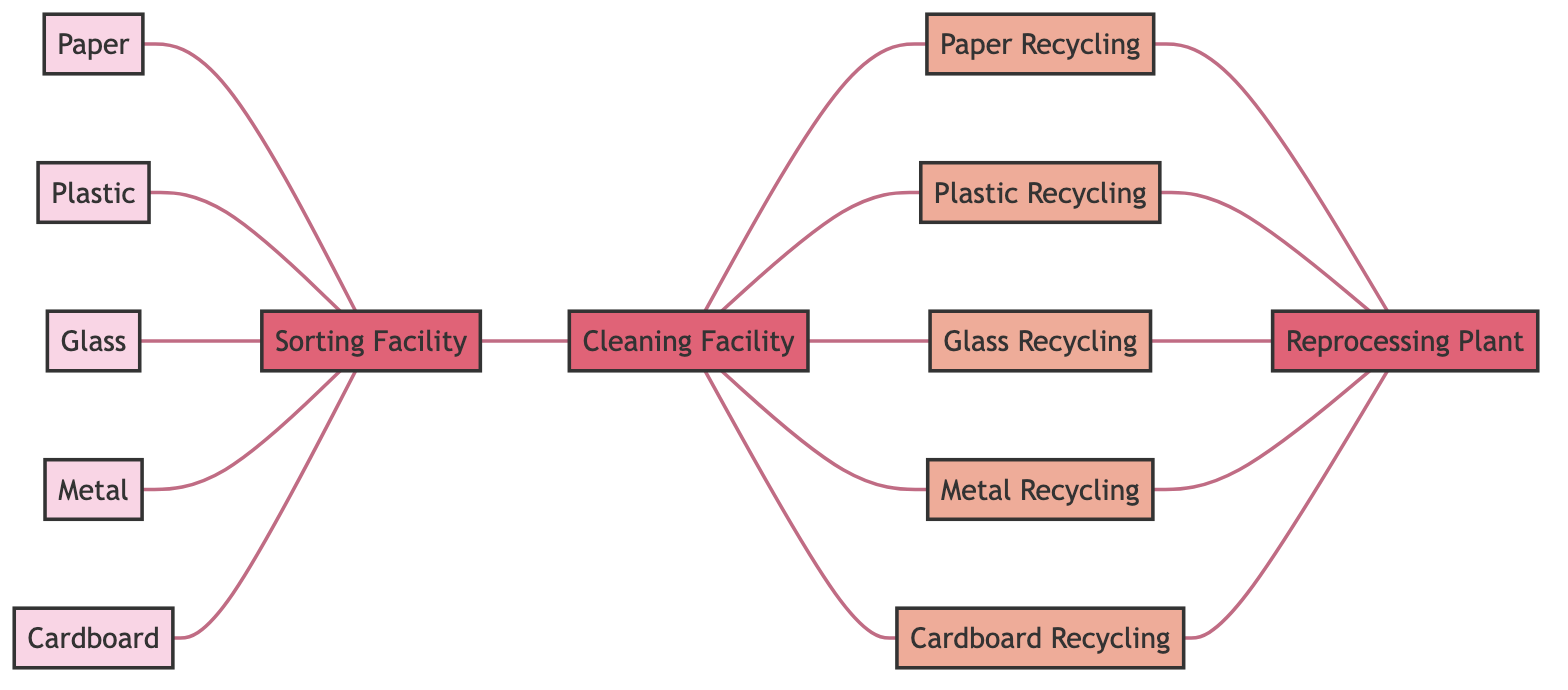What types of materials interact with the Sorting Facility? The nodes directly connected to the Sorting Facility are Paper, Plastic, Glass, Metal, and Cardboard. These materials flow into the Sorting Facility for initial processing.
Answer: Paper, Plastic, Glass, Metal, Cardboard How many recycling processes are depicted in the diagram? The diagram shows five recycling processes: Paper Recycling, Plastic Recycling, Glass Recycling, Metal Recycling, and Cardboard Recycling. Count the nodes labeled as recycling to determine this quantity.
Answer: Five Which facility connects directly to both the Sorting Facility and the Recycling Processes? The Cleaning Facility is connected to the Sorting Facility (as its next step) and to all the Recycling Processes (as the facility that cleans materials before recycling).
Answer: Cleaning Facility What is the last facility in the recycling chain? The Reprocessing Plant is the last facility in the chain, as it is connected only to the recycling processes and not to any other node. This indicates that it is the final stage in the material processing after recycling.
Answer: Reprocessing Plant Which materials are processed at the Cleaning Facility? The Cleaning Facility processes all five types of materials: Paper, Plastic, Glass, Metal, and Cardboard, based on the edges leading from the Cleaning Facility to each respective recycling process.
Answer: Paper, Plastic, Glass, Metal, Cardboard How many edges connect to the Sorting Facility? The Sorting Facility has five edges connecting it to each of the materials: Paper, Plastic, Glass, Metal, and Cardboard. This indicates that it receives all these materials for sorting.
Answer: Five Which two entities are linked directly to each type of Reprocessing Plant? Each type of recycling (Paper, Plastic, Glass, Metal, Cardboard) is directly linked to the Reprocessing Plant. This indicates that all recycling processes ultimately feed into the Reprocessing Plant.
Answer: Recycling Processes What is the role of the Sorting Facility in the recycling process? The Sorting Facility acts as an initial processing stage where various materials are separated for further cleaning and recycling, as indicated by the incoming edges from the nodes representing those materials.
Answer: Initial processing stage 